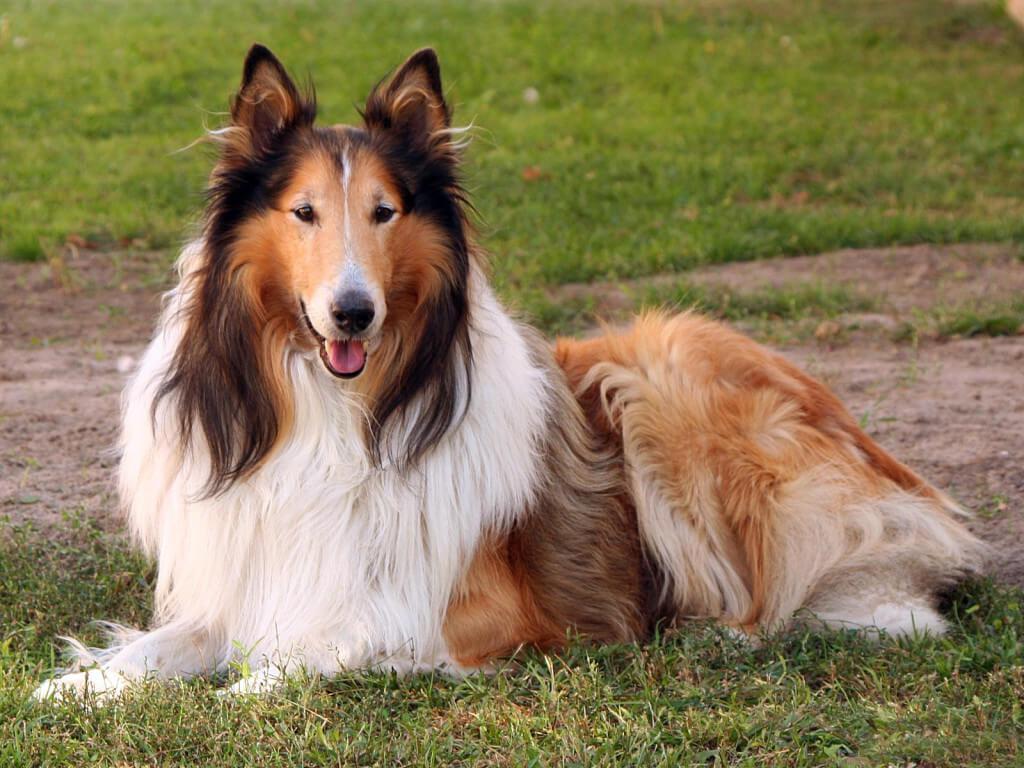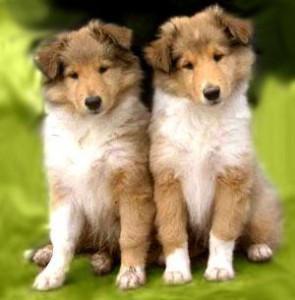The first image is the image on the left, the second image is the image on the right. Evaluate the accuracy of this statement regarding the images: "The left image contains exactly two dogs.". Is it true? Answer yes or no. No. The first image is the image on the left, the second image is the image on the right. For the images shown, is this caption "Young collies are posed sitting upright side-by-side in one image, and the other image shows one collie reclining with its head upright." true? Answer yes or no. Yes. 